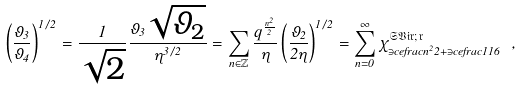Convert formula to latex. <formula><loc_0><loc_0><loc_500><loc_500>\left ( \frac { \vartheta _ { 3 } } { \vartheta _ { 4 } } \right ) ^ { 1 / 2 } = \frac { 1 } { \sqrt { 2 } } \frac { \vartheta _ { 3 } \sqrt { \vartheta _ { 2 } } } { \eta ^ { 3 / 2 } } = \sum _ { n \in \mathbb { Z } } \frac { q ^ { \frac { n ^ { 2 } } { 2 } } } { \eta } \left ( \frac { \vartheta _ { 2 } } { 2 \eta } \right ) ^ { 1 / 2 } = \sum _ { n = 0 } ^ { \infty } \chi ^ { \mathfrak { S V i r ; \, r } } _ { \ni c e f r a c { n ^ { 2 } } { 2 } + \ni c e f r a c { 1 } { 1 6 } } \ ,</formula> 